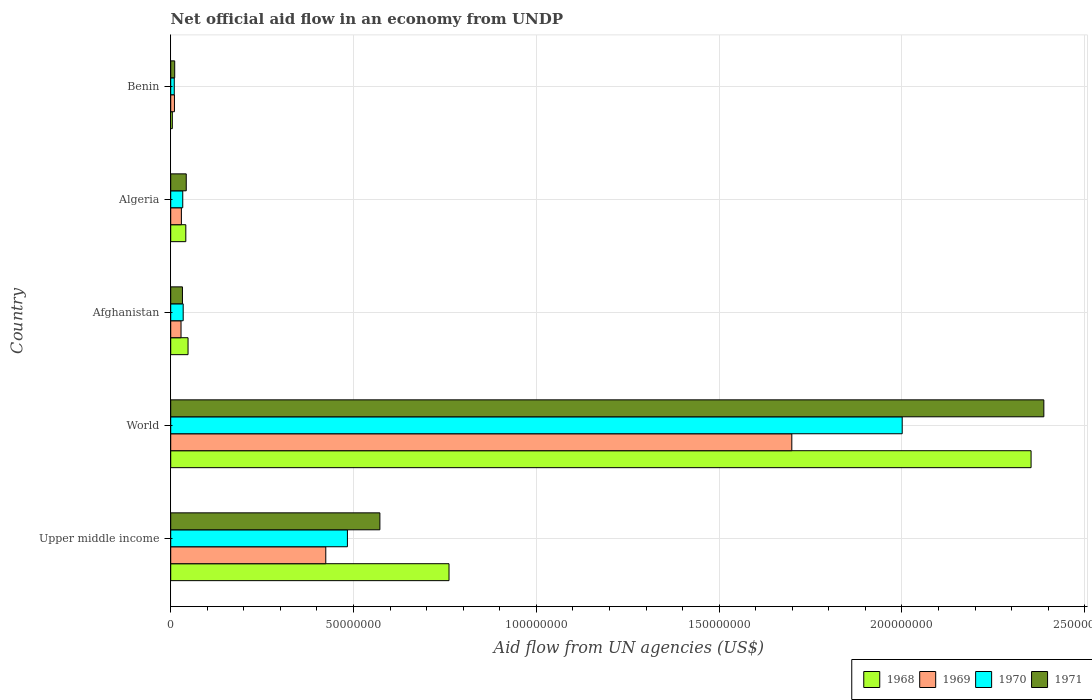How many different coloured bars are there?
Your answer should be very brief. 4. Are the number of bars per tick equal to the number of legend labels?
Offer a very short reply. Yes. How many bars are there on the 4th tick from the top?
Ensure brevity in your answer.  4. What is the label of the 1st group of bars from the top?
Offer a very short reply. Benin. What is the net official aid flow in 1971 in Afghanistan?
Your response must be concise. 3.21e+06. Across all countries, what is the maximum net official aid flow in 1969?
Your answer should be compact. 1.70e+08. Across all countries, what is the minimum net official aid flow in 1970?
Provide a succinct answer. 9.70e+05. In which country was the net official aid flow in 1970 maximum?
Provide a succinct answer. World. In which country was the net official aid flow in 1970 minimum?
Your answer should be very brief. Benin. What is the total net official aid flow in 1970 in the graph?
Ensure brevity in your answer.  2.56e+08. What is the difference between the net official aid flow in 1971 in Benin and that in World?
Provide a succinct answer. -2.38e+08. What is the difference between the net official aid flow in 1969 in Afghanistan and the net official aid flow in 1970 in Algeria?
Ensure brevity in your answer.  -4.70e+05. What is the average net official aid flow in 1971 per country?
Your response must be concise. 6.09e+07. What is the difference between the net official aid flow in 1968 and net official aid flow in 1969 in Afghanistan?
Offer a terse response. 1.92e+06. What is the ratio of the net official aid flow in 1971 in Afghanistan to that in World?
Ensure brevity in your answer.  0.01. What is the difference between the highest and the second highest net official aid flow in 1970?
Your answer should be compact. 1.52e+08. What is the difference between the highest and the lowest net official aid flow in 1970?
Offer a very short reply. 1.99e+08. Is the sum of the net official aid flow in 1970 in Benin and Upper middle income greater than the maximum net official aid flow in 1968 across all countries?
Keep it short and to the point. No. What does the 1st bar from the bottom in Algeria represents?
Ensure brevity in your answer.  1968. Are all the bars in the graph horizontal?
Your answer should be very brief. Yes. How many countries are there in the graph?
Provide a succinct answer. 5. What is the difference between two consecutive major ticks on the X-axis?
Provide a succinct answer. 5.00e+07. Are the values on the major ticks of X-axis written in scientific E-notation?
Make the answer very short. No. Where does the legend appear in the graph?
Offer a very short reply. Bottom right. How are the legend labels stacked?
Your answer should be compact. Horizontal. What is the title of the graph?
Keep it short and to the point. Net official aid flow in an economy from UNDP. Does "1987" appear as one of the legend labels in the graph?
Your answer should be compact. No. What is the label or title of the X-axis?
Make the answer very short. Aid flow from UN agencies (US$). What is the Aid flow from UN agencies (US$) of 1968 in Upper middle income?
Provide a succinct answer. 7.61e+07. What is the Aid flow from UN agencies (US$) of 1969 in Upper middle income?
Give a very brief answer. 4.24e+07. What is the Aid flow from UN agencies (US$) of 1970 in Upper middle income?
Offer a very short reply. 4.83e+07. What is the Aid flow from UN agencies (US$) of 1971 in Upper middle income?
Make the answer very short. 5.72e+07. What is the Aid flow from UN agencies (US$) in 1968 in World?
Give a very brief answer. 2.35e+08. What is the Aid flow from UN agencies (US$) in 1969 in World?
Ensure brevity in your answer.  1.70e+08. What is the Aid flow from UN agencies (US$) in 1970 in World?
Offer a terse response. 2.00e+08. What is the Aid flow from UN agencies (US$) in 1971 in World?
Your response must be concise. 2.39e+08. What is the Aid flow from UN agencies (US$) of 1968 in Afghanistan?
Your response must be concise. 4.74e+06. What is the Aid flow from UN agencies (US$) in 1969 in Afghanistan?
Provide a short and direct response. 2.82e+06. What is the Aid flow from UN agencies (US$) in 1970 in Afghanistan?
Provide a succinct answer. 3.41e+06. What is the Aid flow from UN agencies (US$) in 1971 in Afghanistan?
Offer a very short reply. 3.21e+06. What is the Aid flow from UN agencies (US$) of 1968 in Algeria?
Offer a terse response. 4.13e+06. What is the Aid flow from UN agencies (US$) in 1969 in Algeria?
Provide a short and direct response. 2.92e+06. What is the Aid flow from UN agencies (US$) of 1970 in Algeria?
Keep it short and to the point. 3.29e+06. What is the Aid flow from UN agencies (US$) in 1971 in Algeria?
Offer a very short reply. 4.25e+06. What is the Aid flow from UN agencies (US$) in 1969 in Benin?
Provide a succinct answer. 1.02e+06. What is the Aid flow from UN agencies (US$) of 1970 in Benin?
Offer a terse response. 9.70e+05. What is the Aid flow from UN agencies (US$) in 1971 in Benin?
Your answer should be compact. 1.09e+06. Across all countries, what is the maximum Aid flow from UN agencies (US$) of 1968?
Make the answer very short. 2.35e+08. Across all countries, what is the maximum Aid flow from UN agencies (US$) in 1969?
Keep it short and to the point. 1.70e+08. Across all countries, what is the maximum Aid flow from UN agencies (US$) in 1970?
Offer a very short reply. 2.00e+08. Across all countries, what is the maximum Aid flow from UN agencies (US$) of 1971?
Offer a very short reply. 2.39e+08. Across all countries, what is the minimum Aid flow from UN agencies (US$) in 1969?
Your response must be concise. 1.02e+06. Across all countries, what is the minimum Aid flow from UN agencies (US$) of 1970?
Make the answer very short. 9.70e+05. Across all countries, what is the minimum Aid flow from UN agencies (US$) in 1971?
Ensure brevity in your answer.  1.09e+06. What is the total Aid flow from UN agencies (US$) of 1968 in the graph?
Keep it short and to the point. 3.21e+08. What is the total Aid flow from UN agencies (US$) of 1969 in the graph?
Keep it short and to the point. 2.19e+08. What is the total Aid flow from UN agencies (US$) in 1970 in the graph?
Give a very brief answer. 2.56e+08. What is the total Aid flow from UN agencies (US$) in 1971 in the graph?
Keep it short and to the point. 3.05e+08. What is the difference between the Aid flow from UN agencies (US$) in 1968 in Upper middle income and that in World?
Your answer should be compact. -1.59e+08. What is the difference between the Aid flow from UN agencies (US$) of 1969 in Upper middle income and that in World?
Ensure brevity in your answer.  -1.27e+08. What is the difference between the Aid flow from UN agencies (US$) in 1970 in Upper middle income and that in World?
Offer a very short reply. -1.52e+08. What is the difference between the Aid flow from UN agencies (US$) in 1971 in Upper middle income and that in World?
Provide a short and direct response. -1.82e+08. What is the difference between the Aid flow from UN agencies (US$) of 1968 in Upper middle income and that in Afghanistan?
Your answer should be compact. 7.14e+07. What is the difference between the Aid flow from UN agencies (US$) in 1969 in Upper middle income and that in Afghanistan?
Offer a terse response. 3.96e+07. What is the difference between the Aid flow from UN agencies (US$) of 1970 in Upper middle income and that in Afghanistan?
Provide a short and direct response. 4.49e+07. What is the difference between the Aid flow from UN agencies (US$) of 1971 in Upper middle income and that in Afghanistan?
Make the answer very short. 5.40e+07. What is the difference between the Aid flow from UN agencies (US$) of 1968 in Upper middle income and that in Algeria?
Provide a succinct answer. 7.20e+07. What is the difference between the Aid flow from UN agencies (US$) in 1969 in Upper middle income and that in Algeria?
Offer a very short reply. 3.95e+07. What is the difference between the Aid flow from UN agencies (US$) of 1970 in Upper middle income and that in Algeria?
Provide a short and direct response. 4.50e+07. What is the difference between the Aid flow from UN agencies (US$) of 1971 in Upper middle income and that in Algeria?
Keep it short and to the point. 5.30e+07. What is the difference between the Aid flow from UN agencies (US$) in 1968 in Upper middle income and that in Benin?
Your answer should be compact. 7.57e+07. What is the difference between the Aid flow from UN agencies (US$) of 1969 in Upper middle income and that in Benin?
Your answer should be compact. 4.14e+07. What is the difference between the Aid flow from UN agencies (US$) of 1970 in Upper middle income and that in Benin?
Provide a short and direct response. 4.74e+07. What is the difference between the Aid flow from UN agencies (US$) of 1971 in Upper middle income and that in Benin?
Your answer should be very brief. 5.61e+07. What is the difference between the Aid flow from UN agencies (US$) of 1968 in World and that in Afghanistan?
Offer a terse response. 2.31e+08. What is the difference between the Aid flow from UN agencies (US$) in 1969 in World and that in Afghanistan?
Ensure brevity in your answer.  1.67e+08. What is the difference between the Aid flow from UN agencies (US$) of 1970 in World and that in Afghanistan?
Make the answer very short. 1.97e+08. What is the difference between the Aid flow from UN agencies (US$) in 1971 in World and that in Afghanistan?
Offer a terse response. 2.36e+08. What is the difference between the Aid flow from UN agencies (US$) in 1968 in World and that in Algeria?
Ensure brevity in your answer.  2.31e+08. What is the difference between the Aid flow from UN agencies (US$) in 1969 in World and that in Algeria?
Offer a very short reply. 1.67e+08. What is the difference between the Aid flow from UN agencies (US$) of 1970 in World and that in Algeria?
Your answer should be compact. 1.97e+08. What is the difference between the Aid flow from UN agencies (US$) in 1971 in World and that in Algeria?
Your answer should be very brief. 2.35e+08. What is the difference between the Aid flow from UN agencies (US$) of 1968 in World and that in Benin?
Make the answer very short. 2.35e+08. What is the difference between the Aid flow from UN agencies (US$) in 1969 in World and that in Benin?
Offer a very short reply. 1.69e+08. What is the difference between the Aid flow from UN agencies (US$) of 1970 in World and that in Benin?
Your response must be concise. 1.99e+08. What is the difference between the Aid flow from UN agencies (US$) of 1971 in World and that in Benin?
Offer a terse response. 2.38e+08. What is the difference between the Aid flow from UN agencies (US$) in 1968 in Afghanistan and that in Algeria?
Give a very brief answer. 6.10e+05. What is the difference between the Aid flow from UN agencies (US$) of 1969 in Afghanistan and that in Algeria?
Offer a terse response. -1.00e+05. What is the difference between the Aid flow from UN agencies (US$) in 1971 in Afghanistan and that in Algeria?
Your response must be concise. -1.04e+06. What is the difference between the Aid flow from UN agencies (US$) in 1968 in Afghanistan and that in Benin?
Offer a terse response. 4.30e+06. What is the difference between the Aid flow from UN agencies (US$) of 1969 in Afghanistan and that in Benin?
Your response must be concise. 1.80e+06. What is the difference between the Aid flow from UN agencies (US$) of 1970 in Afghanistan and that in Benin?
Provide a short and direct response. 2.44e+06. What is the difference between the Aid flow from UN agencies (US$) in 1971 in Afghanistan and that in Benin?
Your response must be concise. 2.12e+06. What is the difference between the Aid flow from UN agencies (US$) of 1968 in Algeria and that in Benin?
Your answer should be very brief. 3.69e+06. What is the difference between the Aid flow from UN agencies (US$) of 1969 in Algeria and that in Benin?
Provide a succinct answer. 1.90e+06. What is the difference between the Aid flow from UN agencies (US$) in 1970 in Algeria and that in Benin?
Make the answer very short. 2.32e+06. What is the difference between the Aid flow from UN agencies (US$) of 1971 in Algeria and that in Benin?
Your answer should be very brief. 3.16e+06. What is the difference between the Aid flow from UN agencies (US$) in 1968 in Upper middle income and the Aid flow from UN agencies (US$) in 1969 in World?
Give a very brief answer. -9.38e+07. What is the difference between the Aid flow from UN agencies (US$) of 1968 in Upper middle income and the Aid flow from UN agencies (US$) of 1970 in World?
Make the answer very short. -1.24e+08. What is the difference between the Aid flow from UN agencies (US$) in 1968 in Upper middle income and the Aid flow from UN agencies (US$) in 1971 in World?
Keep it short and to the point. -1.63e+08. What is the difference between the Aid flow from UN agencies (US$) in 1969 in Upper middle income and the Aid flow from UN agencies (US$) in 1970 in World?
Offer a terse response. -1.58e+08. What is the difference between the Aid flow from UN agencies (US$) in 1969 in Upper middle income and the Aid flow from UN agencies (US$) in 1971 in World?
Offer a very short reply. -1.96e+08. What is the difference between the Aid flow from UN agencies (US$) of 1970 in Upper middle income and the Aid flow from UN agencies (US$) of 1971 in World?
Your answer should be very brief. -1.90e+08. What is the difference between the Aid flow from UN agencies (US$) of 1968 in Upper middle income and the Aid flow from UN agencies (US$) of 1969 in Afghanistan?
Make the answer very short. 7.33e+07. What is the difference between the Aid flow from UN agencies (US$) in 1968 in Upper middle income and the Aid flow from UN agencies (US$) in 1970 in Afghanistan?
Ensure brevity in your answer.  7.27e+07. What is the difference between the Aid flow from UN agencies (US$) in 1968 in Upper middle income and the Aid flow from UN agencies (US$) in 1971 in Afghanistan?
Your response must be concise. 7.29e+07. What is the difference between the Aid flow from UN agencies (US$) of 1969 in Upper middle income and the Aid flow from UN agencies (US$) of 1970 in Afghanistan?
Ensure brevity in your answer.  3.90e+07. What is the difference between the Aid flow from UN agencies (US$) in 1969 in Upper middle income and the Aid flow from UN agencies (US$) in 1971 in Afghanistan?
Provide a succinct answer. 3.92e+07. What is the difference between the Aid flow from UN agencies (US$) in 1970 in Upper middle income and the Aid flow from UN agencies (US$) in 1971 in Afghanistan?
Your answer should be very brief. 4.51e+07. What is the difference between the Aid flow from UN agencies (US$) in 1968 in Upper middle income and the Aid flow from UN agencies (US$) in 1969 in Algeria?
Your answer should be very brief. 7.32e+07. What is the difference between the Aid flow from UN agencies (US$) in 1968 in Upper middle income and the Aid flow from UN agencies (US$) in 1970 in Algeria?
Your answer should be very brief. 7.28e+07. What is the difference between the Aid flow from UN agencies (US$) of 1968 in Upper middle income and the Aid flow from UN agencies (US$) of 1971 in Algeria?
Ensure brevity in your answer.  7.19e+07. What is the difference between the Aid flow from UN agencies (US$) in 1969 in Upper middle income and the Aid flow from UN agencies (US$) in 1970 in Algeria?
Make the answer very short. 3.91e+07. What is the difference between the Aid flow from UN agencies (US$) of 1969 in Upper middle income and the Aid flow from UN agencies (US$) of 1971 in Algeria?
Offer a terse response. 3.82e+07. What is the difference between the Aid flow from UN agencies (US$) of 1970 in Upper middle income and the Aid flow from UN agencies (US$) of 1971 in Algeria?
Ensure brevity in your answer.  4.41e+07. What is the difference between the Aid flow from UN agencies (US$) in 1968 in Upper middle income and the Aid flow from UN agencies (US$) in 1969 in Benin?
Your response must be concise. 7.51e+07. What is the difference between the Aid flow from UN agencies (US$) in 1968 in Upper middle income and the Aid flow from UN agencies (US$) in 1970 in Benin?
Your answer should be compact. 7.52e+07. What is the difference between the Aid flow from UN agencies (US$) of 1968 in Upper middle income and the Aid flow from UN agencies (US$) of 1971 in Benin?
Offer a terse response. 7.50e+07. What is the difference between the Aid flow from UN agencies (US$) in 1969 in Upper middle income and the Aid flow from UN agencies (US$) in 1970 in Benin?
Keep it short and to the point. 4.14e+07. What is the difference between the Aid flow from UN agencies (US$) in 1969 in Upper middle income and the Aid flow from UN agencies (US$) in 1971 in Benin?
Keep it short and to the point. 4.13e+07. What is the difference between the Aid flow from UN agencies (US$) in 1970 in Upper middle income and the Aid flow from UN agencies (US$) in 1971 in Benin?
Keep it short and to the point. 4.72e+07. What is the difference between the Aid flow from UN agencies (US$) of 1968 in World and the Aid flow from UN agencies (US$) of 1969 in Afghanistan?
Provide a short and direct response. 2.32e+08. What is the difference between the Aid flow from UN agencies (US$) in 1968 in World and the Aid flow from UN agencies (US$) in 1970 in Afghanistan?
Give a very brief answer. 2.32e+08. What is the difference between the Aid flow from UN agencies (US$) in 1968 in World and the Aid flow from UN agencies (US$) in 1971 in Afghanistan?
Provide a succinct answer. 2.32e+08. What is the difference between the Aid flow from UN agencies (US$) in 1969 in World and the Aid flow from UN agencies (US$) in 1970 in Afghanistan?
Your answer should be very brief. 1.66e+08. What is the difference between the Aid flow from UN agencies (US$) in 1969 in World and the Aid flow from UN agencies (US$) in 1971 in Afghanistan?
Ensure brevity in your answer.  1.67e+08. What is the difference between the Aid flow from UN agencies (US$) in 1970 in World and the Aid flow from UN agencies (US$) in 1971 in Afghanistan?
Offer a terse response. 1.97e+08. What is the difference between the Aid flow from UN agencies (US$) in 1968 in World and the Aid flow from UN agencies (US$) in 1969 in Algeria?
Offer a terse response. 2.32e+08. What is the difference between the Aid flow from UN agencies (US$) in 1968 in World and the Aid flow from UN agencies (US$) in 1970 in Algeria?
Make the answer very short. 2.32e+08. What is the difference between the Aid flow from UN agencies (US$) in 1968 in World and the Aid flow from UN agencies (US$) in 1971 in Algeria?
Your answer should be compact. 2.31e+08. What is the difference between the Aid flow from UN agencies (US$) in 1969 in World and the Aid flow from UN agencies (US$) in 1970 in Algeria?
Your answer should be very brief. 1.67e+08. What is the difference between the Aid flow from UN agencies (US$) in 1969 in World and the Aid flow from UN agencies (US$) in 1971 in Algeria?
Provide a succinct answer. 1.66e+08. What is the difference between the Aid flow from UN agencies (US$) of 1970 in World and the Aid flow from UN agencies (US$) of 1971 in Algeria?
Your response must be concise. 1.96e+08. What is the difference between the Aid flow from UN agencies (US$) of 1968 in World and the Aid flow from UN agencies (US$) of 1969 in Benin?
Keep it short and to the point. 2.34e+08. What is the difference between the Aid flow from UN agencies (US$) of 1968 in World and the Aid flow from UN agencies (US$) of 1970 in Benin?
Give a very brief answer. 2.34e+08. What is the difference between the Aid flow from UN agencies (US$) of 1968 in World and the Aid flow from UN agencies (US$) of 1971 in Benin?
Ensure brevity in your answer.  2.34e+08. What is the difference between the Aid flow from UN agencies (US$) of 1969 in World and the Aid flow from UN agencies (US$) of 1970 in Benin?
Your answer should be very brief. 1.69e+08. What is the difference between the Aid flow from UN agencies (US$) in 1969 in World and the Aid flow from UN agencies (US$) in 1971 in Benin?
Ensure brevity in your answer.  1.69e+08. What is the difference between the Aid flow from UN agencies (US$) in 1970 in World and the Aid flow from UN agencies (US$) in 1971 in Benin?
Your answer should be very brief. 1.99e+08. What is the difference between the Aid flow from UN agencies (US$) of 1968 in Afghanistan and the Aid flow from UN agencies (US$) of 1969 in Algeria?
Give a very brief answer. 1.82e+06. What is the difference between the Aid flow from UN agencies (US$) of 1968 in Afghanistan and the Aid flow from UN agencies (US$) of 1970 in Algeria?
Make the answer very short. 1.45e+06. What is the difference between the Aid flow from UN agencies (US$) in 1968 in Afghanistan and the Aid flow from UN agencies (US$) in 1971 in Algeria?
Provide a succinct answer. 4.90e+05. What is the difference between the Aid flow from UN agencies (US$) in 1969 in Afghanistan and the Aid flow from UN agencies (US$) in 1970 in Algeria?
Offer a terse response. -4.70e+05. What is the difference between the Aid flow from UN agencies (US$) of 1969 in Afghanistan and the Aid flow from UN agencies (US$) of 1971 in Algeria?
Make the answer very short. -1.43e+06. What is the difference between the Aid flow from UN agencies (US$) in 1970 in Afghanistan and the Aid flow from UN agencies (US$) in 1971 in Algeria?
Your answer should be compact. -8.40e+05. What is the difference between the Aid flow from UN agencies (US$) of 1968 in Afghanistan and the Aid flow from UN agencies (US$) of 1969 in Benin?
Your answer should be very brief. 3.72e+06. What is the difference between the Aid flow from UN agencies (US$) of 1968 in Afghanistan and the Aid flow from UN agencies (US$) of 1970 in Benin?
Make the answer very short. 3.77e+06. What is the difference between the Aid flow from UN agencies (US$) in 1968 in Afghanistan and the Aid flow from UN agencies (US$) in 1971 in Benin?
Provide a succinct answer. 3.65e+06. What is the difference between the Aid flow from UN agencies (US$) of 1969 in Afghanistan and the Aid flow from UN agencies (US$) of 1970 in Benin?
Offer a terse response. 1.85e+06. What is the difference between the Aid flow from UN agencies (US$) in 1969 in Afghanistan and the Aid flow from UN agencies (US$) in 1971 in Benin?
Give a very brief answer. 1.73e+06. What is the difference between the Aid flow from UN agencies (US$) in 1970 in Afghanistan and the Aid flow from UN agencies (US$) in 1971 in Benin?
Your response must be concise. 2.32e+06. What is the difference between the Aid flow from UN agencies (US$) of 1968 in Algeria and the Aid flow from UN agencies (US$) of 1969 in Benin?
Give a very brief answer. 3.11e+06. What is the difference between the Aid flow from UN agencies (US$) of 1968 in Algeria and the Aid flow from UN agencies (US$) of 1970 in Benin?
Provide a short and direct response. 3.16e+06. What is the difference between the Aid flow from UN agencies (US$) in 1968 in Algeria and the Aid flow from UN agencies (US$) in 1971 in Benin?
Your response must be concise. 3.04e+06. What is the difference between the Aid flow from UN agencies (US$) of 1969 in Algeria and the Aid flow from UN agencies (US$) of 1970 in Benin?
Ensure brevity in your answer.  1.95e+06. What is the difference between the Aid flow from UN agencies (US$) in 1969 in Algeria and the Aid flow from UN agencies (US$) in 1971 in Benin?
Your answer should be very brief. 1.83e+06. What is the difference between the Aid flow from UN agencies (US$) in 1970 in Algeria and the Aid flow from UN agencies (US$) in 1971 in Benin?
Offer a terse response. 2.20e+06. What is the average Aid flow from UN agencies (US$) of 1968 per country?
Offer a terse response. 6.42e+07. What is the average Aid flow from UN agencies (US$) of 1969 per country?
Keep it short and to the point. 4.38e+07. What is the average Aid flow from UN agencies (US$) in 1970 per country?
Make the answer very short. 5.12e+07. What is the average Aid flow from UN agencies (US$) in 1971 per country?
Your answer should be compact. 6.09e+07. What is the difference between the Aid flow from UN agencies (US$) in 1968 and Aid flow from UN agencies (US$) in 1969 in Upper middle income?
Keep it short and to the point. 3.37e+07. What is the difference between the Aid flow from UN agencies (US$) of 1968 and Aid flow from UN agencies (US$) of 1970 in Upper middle income?
Make the answer very short. 2.78e+07. What is the difference between the Aid flow from UN agencies (US$) in 1968 and Aid flow from UN agencies (US$) in 1971 in Upper middle income?
Keep it short and to the point. 1.89e+07. What is the difference between the Aid flow from UN agencies (US$) of 1969 and Aid flow from UN agencies (US$) of 1970 in Upper middle income?
Ensure brevity in your answer.  -5.92e+06. What is the difference between the Aid flow from UN agencies (US$) of 1969 and Aid flow from UN agencies (US$) of 1971 in Upper middle income?
Give a very brief answer. -1.48e+07. What is the difference between the Aid flow from UN agencies (US$) of 1970 and Aid flow from UN agencies (US$) of 1971 in Upper middle income?
Keep it short and to the point. -8.88e+06. What is the difference between the Aid flow from UN agencies (US$) of 1968 and Aid flow from UN agencies (US$) of 1969 in World?
Offer a very short reply. 6.54e+07. What is the difference between the Aid flow from UN agencies (US$) in 1968 and Aid flow from UN agencies (US$) in 1970 in World?
Offer a very short reply. 3.52e+07. What is the difference between the Aid flow from UN agencies (US$) in 1968 and Aid flow from UN agencies (US$) in 1971 in World?
Your response must be concise. -3.49e+06. What is the difference between the Aid flow from UN agencies (US$) in 1969 and Aid flow from UN agencies (US$) in 1970 in World?
Offer a very short reply. -3.02e+07. What is the difference between the Aid flow from UN agencies (US$) of 1969 and Aid flow from UN agencies (US$) of 1971 in World?
Your response must be concise. -6.89e+07. What is the difference between the Aid flow from UN agencies (US$) in 1970 and Aid flow from UN agencies (US$) in 1971 in World?
Make the answer very short. -3.87e+07. What is the difference between the Aid flow from UN agencies (US$) of 1968 and Aid flow from UN agencies (US$) of 1969 in Afghanistan?
Your answer should be very brief. 1.92e+06. What is the difference between the Aid flow from UN agencies (US$) of 1968 and Aid flow from UN agencies (US$) of 1970 in Afghanistan?
Make the answer very short. 1.33e+06. What is the difference between the Aid flow from UN agencies (US$) in 1968 and Aid flow from UN agencies (US$) in 1971 in Afghanistan?
Offer a terse response. 1.53e+06. What is the difference between the Aid flow from UN agencies (US$) in 1969 and Aid flow from UN agencies (US$) in 1970 in Afghanistan?
Your response must be concise. -5.90e+05. What is the difference between the Aid flow from UN agencies (US$) in 1969 and Aid flow from UN agencies (US$) in 1971 in Afghanistan?
Your response must be concise. -3.90e+05. What is the difference between the Aid flow from UN agencies (US$) in 1968 and Aid flow from UN agencies (US$) in 1969 in Algeria?
Ensure brevity in your answer.  1.21e+06. What is the difference between the Aid flow from UN agencies (US$) of 1968 and Aid flow from UN agencies (US$) of 1970 in Algeria?
Give a very brief answer. 8.40e+05. What is the difference between the Aid flow from UN agencies (US$) of 1968 and Aid flow from UN agencies (US$) of 1971 in Algeria?
Your answer should be very brief. -1.20e+05. What is the difference between the Aid flow from UN agencies (US$) in 1969 and Aid flow from UN agencies (US$) in 1970 in Algeria?
Your response must be concise. -3.70e+05. What is the difference between the Aid flow from UN agencies (US$) of 1969 and Aid flow from UN agencies (US$) of 1971 in Algeria?
Ensure brevity in your answer.  -1.33e+06. What is the difference between the Aid flow from UN agencies (US$) in 1970 and Aid flow from UN agencies (US$) in 1971 in Algeria?
Offer a terse response. -9.60e+05. What is the difference between the Aid flow from UN agencies (US$) in 1968 and Aid flow from UN agencies (US$) in 1969 in Benin?
Make the answer very short. -5.80e+05. What is the difference between the Aid flow from UN agencies (US$) of 1968 and Aid flow from UN agencies (US$) of 1970 in Benin?
Keep it short and to the point. -5.30e+05. What is the difference between the Aid flow from UN agencies (US$) in 1968 and Aid flow from UN agencies (US$) in 1971 in Benin?
Offer a very short reply. -6.50e+05. What is the difference between the Aid flow from UN agencies (US$) in 1969 and Aid flow from UN agencies (US$) in 1970 in Benin?
Provide a succinct answer. 5.00e+04. What is the ratio of the Aid flow from UN agencies (US$) in 1968 in Upper middle income to that in World?
Keep it short and to the point. 0.32. What is the ratio of the Aid flow from UN agencies (US$) in 1969 in Upper middle income to that in World?
Make the answer very short. 0.25. What is the ratio of the Aid flow from UN agencies (US$) of 1970 in Upper middle income to that in World?
Your response must be concise. 0.24. What is the ratio of the Aid flow from UN agencies (US$) in 1971 in Upper middle income to that in World?
Give a very brief answer. 0.24. What is the ratio of the Aid flow from UN agencies (US$) of 1968 in Upper middle income to that in Afghanistan?
Your response must be concise. 16.06. What is the ratio of the Aid flow from UN agencies (US$) of 1969 in Upper middle income to that in Afghanistan?
Provide a short and direct response. 15.04. What is the ratio of the Aid flow from UN agencies (US$) in 1970 in Upper middle income to that in Afghanistan?
Offer a terse response. 14.17. What is the ratio of the Aid flow from UN agencies (US$) in 1971 in Upper middle income to that in Afghanistan?
Your answer should be compact. 17.82. What is the ratio of the Aid flow from UN agencies (US$) of 1968 in Upper middle income to that in Algeria?
Your answer should be compact. 18.43. What is the ratio of the Aid flow from UN agencies (US$) in 1969 in Upper middle income to that in Algeria?
Make the answer very short. 14.52. What is the ratio of the Aid flow from UN agencies (US$) of 1970 in Upper middle income to that in Algeria?
Ensure brevity in your answer.  14.69. What is the ratio of the Aid flow from UN agencies (US$) in 1971 in Upper middle income to that in Algeria?
Your answer should be compact. 13.46. What is the ratio of the Aid flow from UN agencies (US$) in 1968 in Upper middle income to that in Benin?
Offer a terse response. 173. What is the ratio of the Aid flow from UN agencies (US$) of 1969 in Upper middle income to that in Benin?
Ensure brevity in your answer.  41.58. What is the ratio of the Aid flow from UN agencies (US$) of 1970 in Upper middle income to that in Benin?
Give a very brief answer. 49.82. What is the ratio of the Aid flow from UN agencies (US$) in 1971 in Upper middle income to that in Benin?
Your answer should be compact. 52.49. What is the ratio of the Aid flow from UN agencies (US$) in 1968 in World to that in Afghanistan?
Provide a short and direct response. 49.65. What is the ratio of the Aid flow from UN agencies (US$) in 1969 in World to that in Afghanistan?
Offer a terse response. 60.24. What is the ratio of the Aid flow from UN agencies (US$) of 1970 in World to that in Afghanistan?
Provide a short and direct response. 58.67. What is the ratio of the Aid flow from UN agencies (US$) in 1971 in World to that in Afghanistan?
Provide a short and direct response. 74.4. What is the ratio of the Aid flow from UN agencies (US$) of 1968 in World to that in Algeria?
Give a very brief answer. 56.98. What is the ratio of the Aid flow from UN agencies (US$) in 1969 in World to that in Algeria?
Provide a short and direct response. 58.18. What is the ratio of the Aid flow from UN agencies (US$) in 1970 in World to that in Algeria?
Your answer should be compact. 60.81. What is the ratio of the Aid flow from UN agencies (US$) in 1971 in World to that in Algeria?
Provide a succinct answer. 56.19. What is the ratio of the Aid flow from UN agencies (US$) in 1968 in World to that in Benin?
Your answer should be compact. 534.82. What is the ratio of the Aid flow from UN agencies (US$) in 1969 in World to that in Benin?
Offer a terse response. 166.55. What is the ratio of the Aid flow from UN agencies (US$) in 1970 in World to that in Benin?
Ensure brevity in your answer.  206.26. What is the ratio of the Aid flow from UN agencies (US$) of 1971 in World to that in Benin?
Give a very brief answer. 219.09. What is the ratio of the Aid flow from UN agencies (US$) of 1968 in Afghanistan to that in Algeria?
Make the answer very short. 1.15. What is the ratio of the Aid flow from UN agencies (US$) of 1969 in Afghanistan to that in Algeria?
Offer a very short reply. 0.97. What is the ratio of the Aid flow from UN agencies (US$) in 1970 in Afghanistan to that in Algeria?
Your answer should be compact. 1.04. What is the ratio of the Aid flow from UN agencies (US$) in 1971 in Afghanistan to that in Algeria?
Your answer should be very brief. 0.76. What is the ratio of the Aid flow from UN agencies (US$) in 1968 in Afghanistan to that in Benin?
Keep it short and to the point. 10.77. What is the ratio of the Aid flow from UN agencies (US$) in 1969 in Afghanistan to that in Benin?
Offer a terse response. 2.76. What is the ratio of the Aid flow from UN agencies (US$) of 1970 in Afghanistan to that in Benin?
Offer a terse response. 3.52. What is the ratio of the Aid flow from UN agencies (US$) in 1971 in Afghanistan to that in Benin?
Ensure brevity in your answer.  2.94. What is the ratio of the Aid flow from UN agencies (US$) of 1968 in Algeria to that in Benin?
Offer a very short reply. 9.39. What is the ratio of the Aid flow from UN agencies (US$) in 1969 in Algeria to that in Benin?
Your answer should be compact. 2.86. What is the ratio of the Aid flow from UN agencies (US$) in 1970 in Algeria to that in Benin?
Give a very brief answer. 3.39. What is the ratio of the Aid flow from UN agencies (US$) of 1971 in Algeria to that in Benin?
Your response must be concise. 3.9. What is the difference between the highest and the second highest Aid flow from UN agencies (US$) in 1968?
Offer a very short reply. 1.59e+08. What is the difference between the highest and the second highest Aid flow from UN agencies (US$) of 1969?
Your response must be concise. 1.27e+08. What is the difference between the highest and the second highest Aid flow from UN agencies (US$) in 1970?
Your answer should be very brief. 1.52e+08. What is the difference between the highest and the second highest Aid flow from UN agencies (US$) of 1971?
Make the answer very short. 1.82e+08. What is the difference between the highest and the lowest Aid flow from UN agencies (US$) in 1968?
Offer a terse response. 2.35e+08. What is the difference between the highest and the lowest Aid flow from UN agencies (US$) of 1969?
Give a very brief answer. 1.69e+08. What is the difference between the highest and the lowest Aid flow from UN agencies (US$) in 1970?
Offer a very short reply. 1.99e+08. What is the difference between the highest and the lowest Aid flow from UN agencies (US$) in 1971?
Keep it short and to the point. 2.38e+08. 